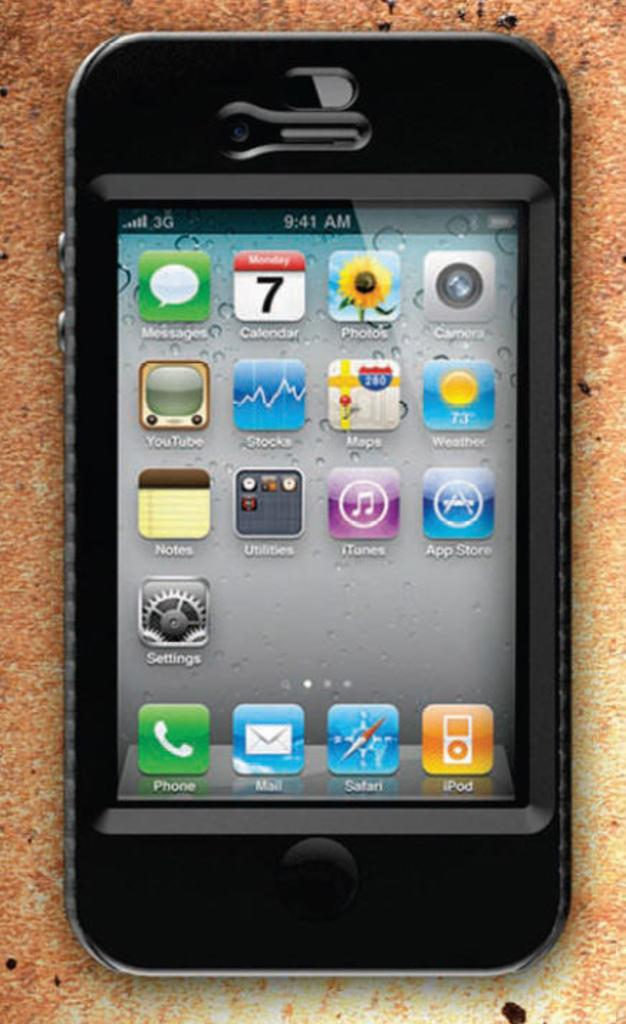Provide a one-sentence caption for the provided image. A black iPhone has a bunch of apps installed including Messages, Calendar and Photos among others. 